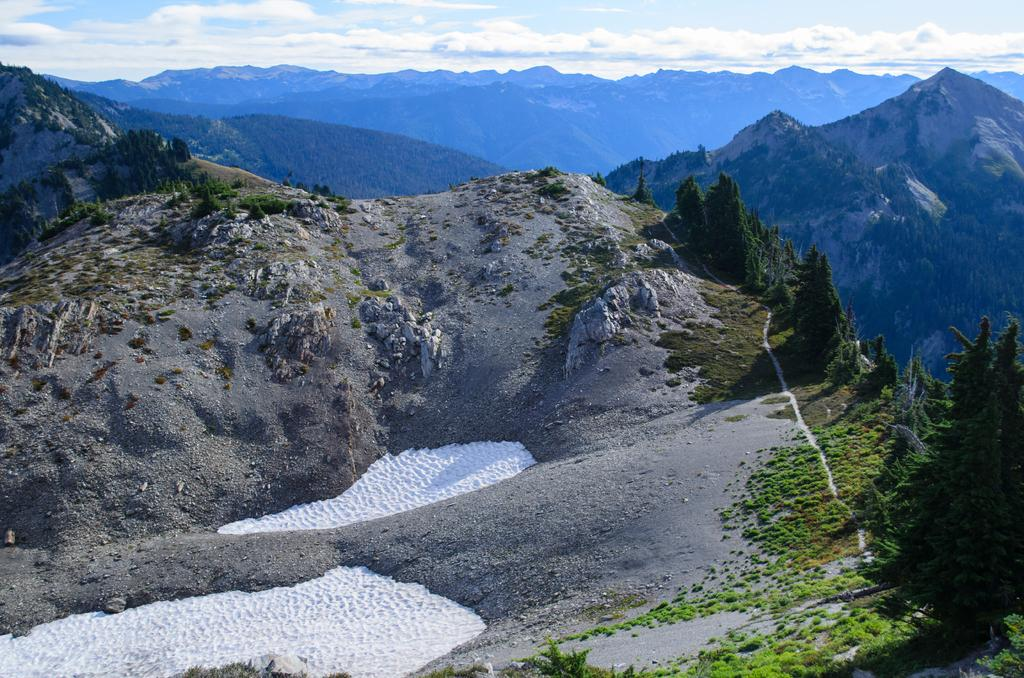What type of vegetation can be seen in the image? There is a group of trees and plants in the image. What can be used to travel along the area in the image? There is a pathway in the image that can be used for traveling. What is the condition of the hills in the image? The hills in the image have snow on them. What is visible in the background of the image? Mountains and the sky are visible in the background of the image. What is the weather like in the image? The sky appears cloudy in the image, suggesting a potentially overcast or snowy day. Can you hear the voice of the instrument playing in the image? There is no voice or instrument playing in the image; it features a landscape with trees, plants, a pathway, snowy hills, mountains, and a cloudy sky. 